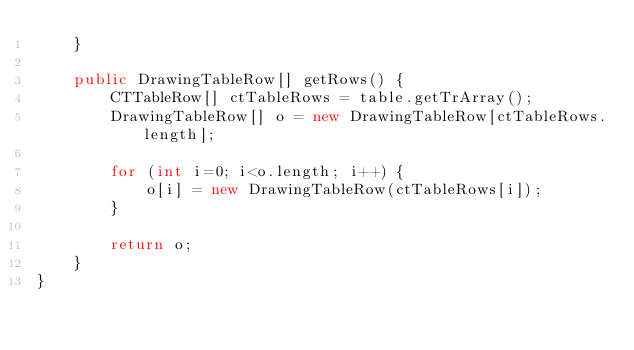Convert code to text. <code><loc_0><loc_0><loc_500><loc_500><_Java_>    }

    public DrawingTableRow[] getRows() {
        CTTableRow[] ctTableRows = table.getTrArray();
        DrawingTableRow[] o = new DrawingTableRow[ctTableRows.length];

        for (int i=0; i<o.length; i++) {
            o[i] = new DrawingTableRow(ctTableRows[i]);
        }

        return o;
    }
}
</code> 